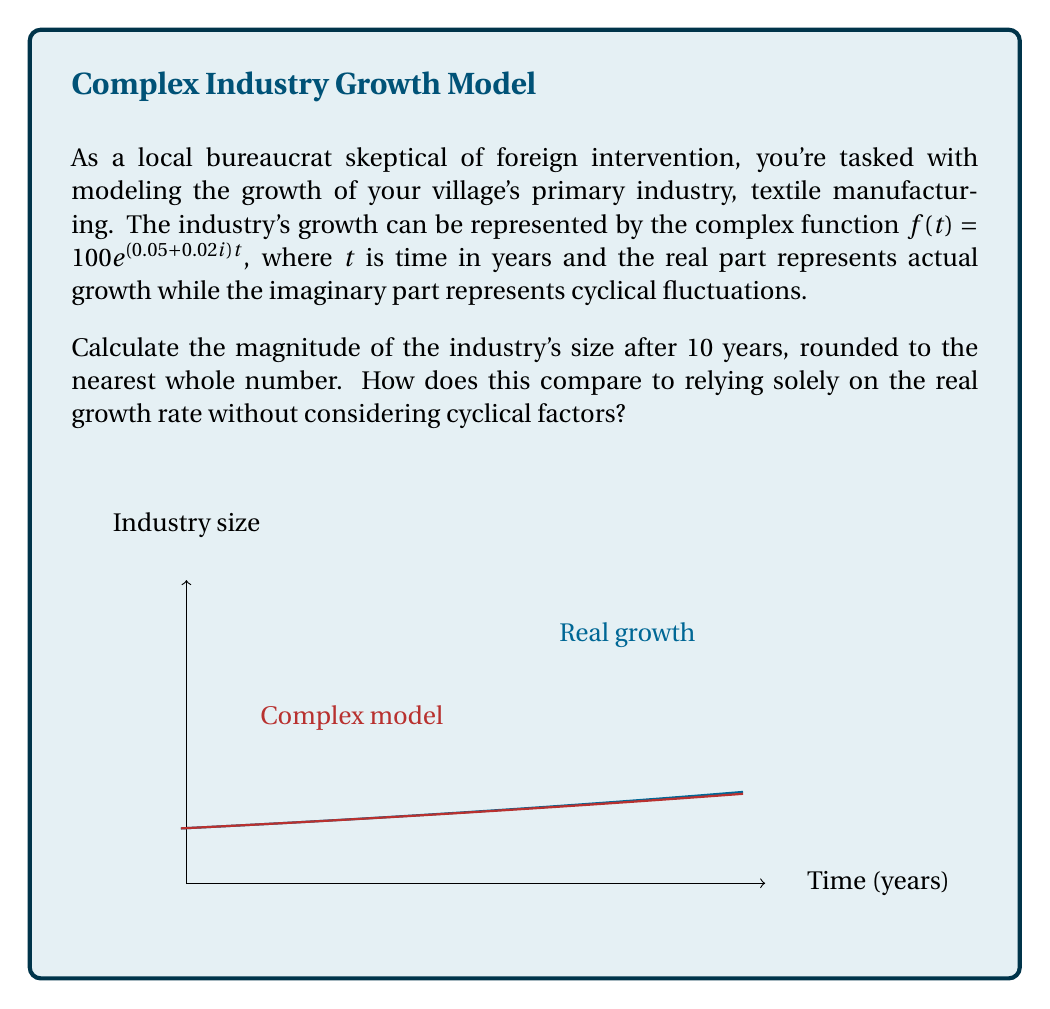What is the answer to this math problem? Let's approach this step-by-step:

1) The given function is $f(t) = 100e^{(0.05+0.02i)t}$

2) To find the magnitude after 10 years, we need to calculate $|f(10)|$

3) $|f(10)| = |100e^{(0.05+0.02i)10}|$

4) Using the properties of complex exponentials:
   $|100e^{(0.05+0.02i)10}| = 100|e^{0.5+0.2i}|$

5) For a complex number $z = a+bi$, $|e^z| = e^a$. Therefore:
   $100|e^{0.5+0.2i}| = 100e^{0.5}$

6) Calculate: $100e^{0.5} \approx 164.87$

7) Rounding to the nearest whole number: 165

8) To compare with real growth only:
   Real growth: $100e^{0.05*10} \approx 164.87$

9) The result is the same when rounded, but the complex model accounts for cyclical fluctuations which could be important for short-term planning.
Answer: 165 